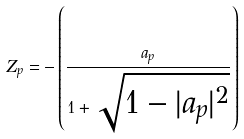<formula> <loc_0><loc_0><loc_500><loc_500>Z _ { p } = - \left ( \frac { a _ { p } } { 1 + \sqrt { 1 - | a _ { p } | ^ { 2 } } } \right )</formula> 